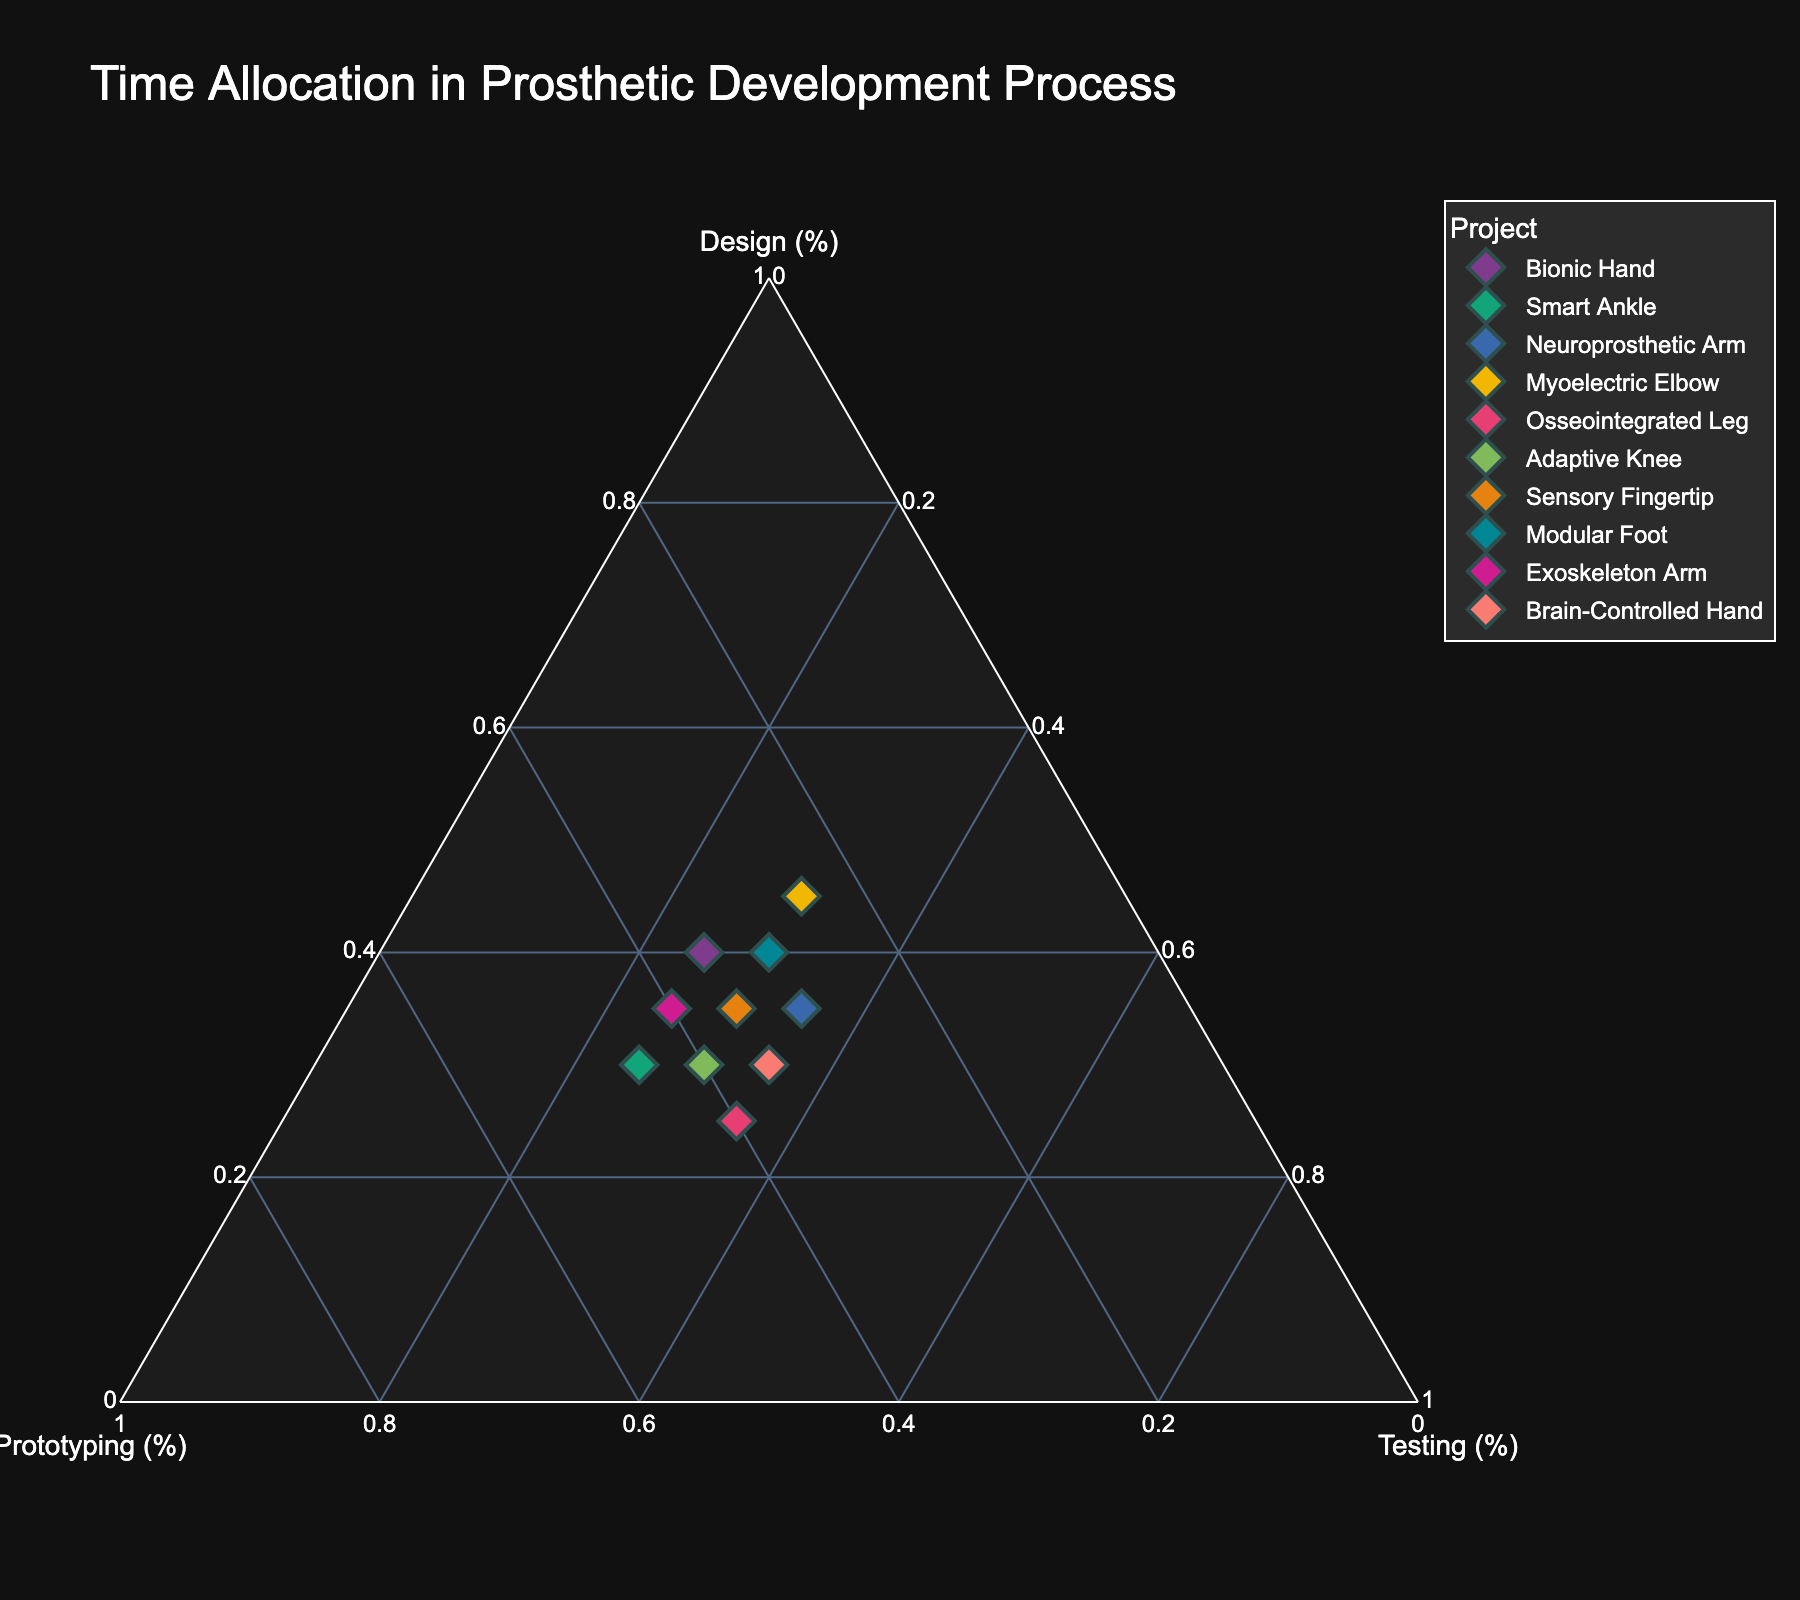what is the project name that allocates 45% of its time to the design phase? Look at the data points in the ternary plot and identify the one where the design value is 45%. The corresponding project name is “Myoelectric Elbow.”
Answer: Myoelectric Elbow Which project has the highest allocation in the prototyping phase? To find the project with the highest allocation in prototyping, identify the data point with the maximum value in the prototyping axis. That project is “Smart Ankle” with 45%.
Answer: Smart Ankle How many projects allocate 35% of their time to testing? Count the number of data points where the testing value is 35%. The projects are "Neuroprosthetic Arm," "Osseointegrated Leg," and "Brain-Controlled Hand," totaling 3 projects.
Answer: 3 Which projects have a balanced time allocation (same percentage) for design and prototyping? Identify the data points that have equal values for the design and prototyping phases. The projects with balanced time allocation are “Bionic Hand” and “Sensory Fingertip,” both having 35% each.
Answer: Bionic Hand, Sensory Fingertip What is the average time allocation for the design phase across all projects? Sum up the design allocations for all projects and divide by the number of projects: (40+30+35+45+25+30+35+40+35+30)/10 = 34.5%.
Answer: 34.5% Which project spends more time on testing than on design? Compare the design and testing values for each data point to see which has a higher testing percentage. The project "Neuroprosthetic Arm" has 35% for both design and testing, but no other project meets the criteria. Thus, one project fits the condition.
Answer: Neuroprosthetic Arm What proportion of projects allocate more than 40% to the design phase? Count the projects with design phases over 40% and divide by the total number of projects. “Bionic Hand,” “Myoelectric Elbow,” and “Modular Foot” meet the criteria: 3/10 = 0.3 or 30%.
Answer: 30% Which project allocates the least amount of time to testing? Locate the data point with the smallest testing value. Both "Bionic Hand" and "Exoskeleton Arm" allocate 25% to testing, which is the minimum.
Answer: Bionic Hand, Exoskeleton Arm How does the time allocation for "Adaptive Knee" compare among the three phases? Look at the slices or percentages for Adaptive Knee: 30% design, 40% prototyping, and 30% testing. The prototyping phase has the highest allocation, while design and testing are equal.
Answer: Prototyping > Design = Testing 